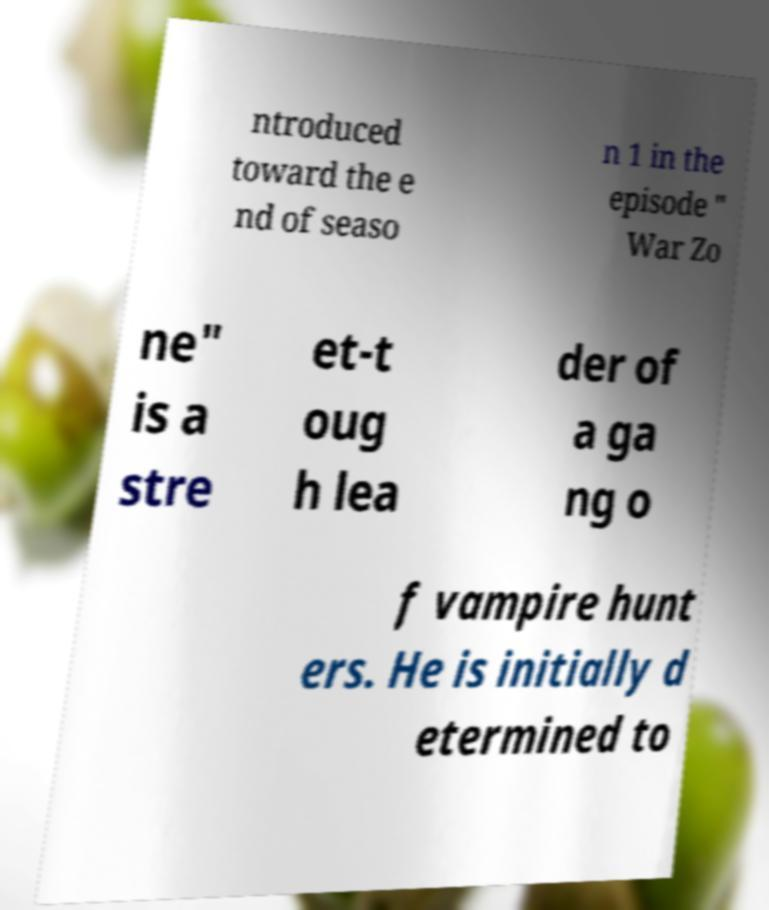Please identify and transcribe the text found in this image. ntroduced toward the e nd of seaso n 1 in the episode " War Zo ne" is a stre et-t oug h lea der of a ga ng o f vampire hunt ers. He is initially d etermined to 